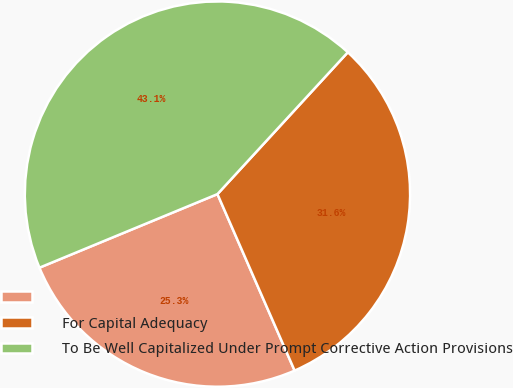Convert chart to OTSL. <chart><loc_0><loc_0><loc_500><loc_500><pie_chart><ecel><fcel>For Capital Adequacy<fcel>To Be Well Capitalized Under Prompt Corrective Action Provisions<nl><fcel>25.32%<fcel>31.61%<fcel>43.07%<nl></chart> 